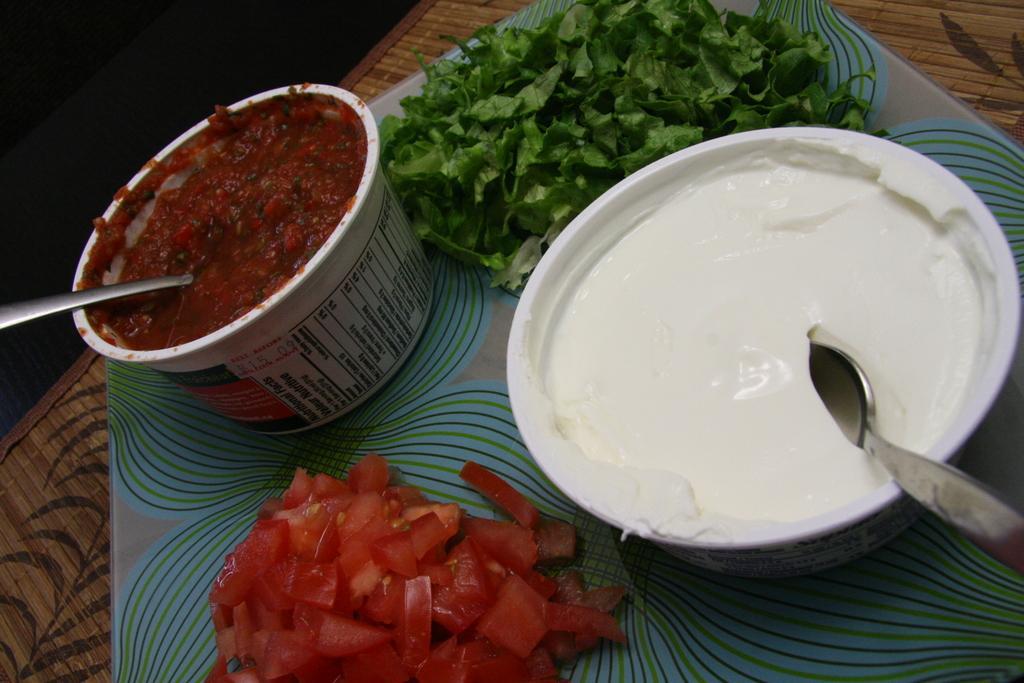In one or two sentences, can you explain what this image depicts? In the center of the image we can see one table. On the table, we can see one plate. In the plate, we can see plastic bowls, tomato slices and leafy vegetables. In the bowls, we can see the spoons, curd and some food items. 